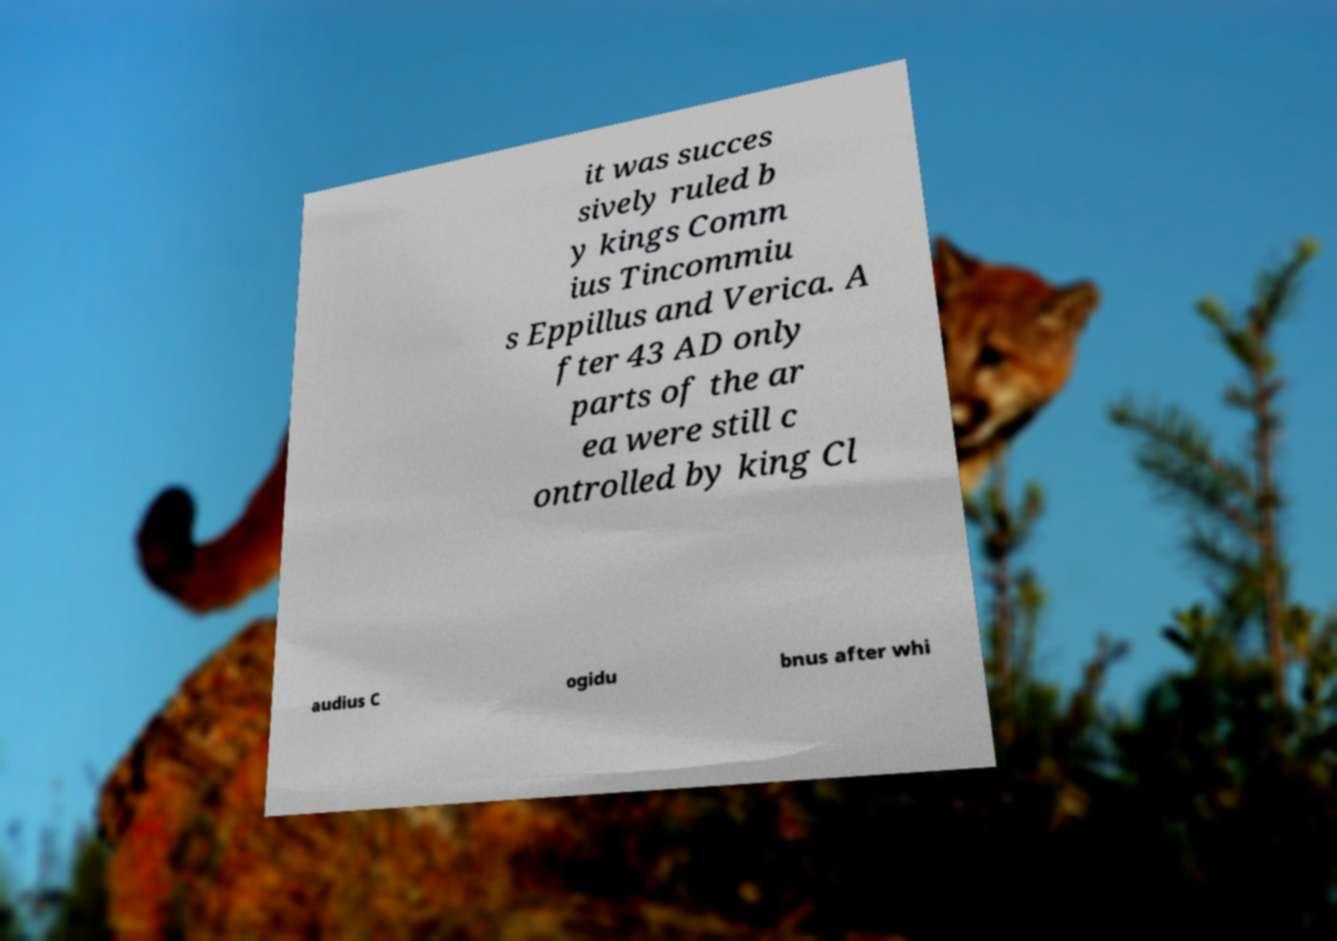Could you assist in decoding the text presented in this image and type it out clearly? it was succes sively ruled b y kings Comm ius Tincommiu s Eppillus and Verica. A fter 43 AD only parts of the ar ea were still c ontrolled by king Cl audius C ogidu bnus after whi 